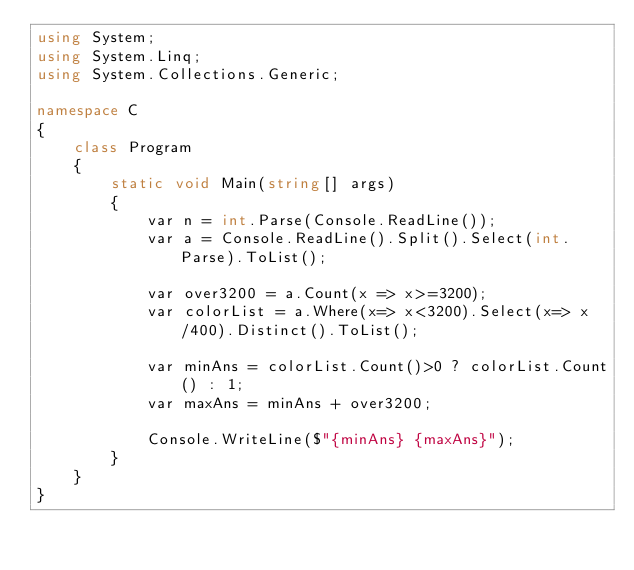Convert code to text. <code><loc_0><loc_0><loc_500><loc_500><_C#_>using System;
using System.Linq;
using System.Collections.Generic;

namespace C
{
    class Program
    {
        static void Main(string[] args)
        {
            var n = int.Parse(Console.ReadLine());
            var a = Console.ReadLine().Split().Select(int.Parse).ToList();
            
            var over3200 = a.Count(x => x>=3200);
            var colorList = a.Where(x=> x<3200).Select(x=> x/400).Distinct().ToList();

            var minAns = colorList.Count()>0 ? colorList.Count() : 1;
            var maxAns = minAns + over3200;

            Console.WriteLine($"{minAns} {maxAns}");
        }
    }
}
</code> 